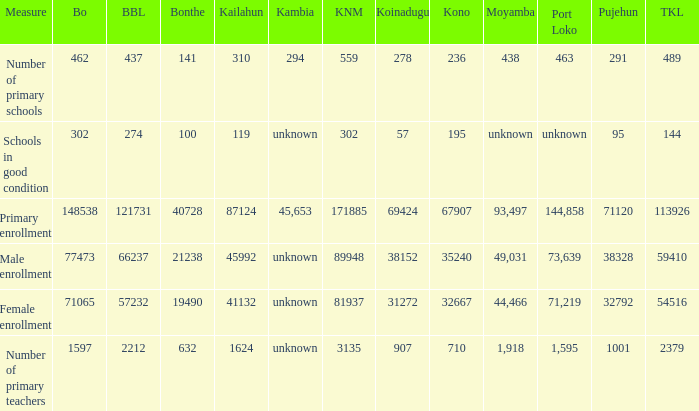Can you give me this table as a dict? {'header': ['Measure', 'Bo', 'BBL', 'Bonthe', 'Kailahun', 'Kambia', 'KNM', 'Koinadugu', 'Kono', 'Moyamba', 'Port Loko', 'Pujehun', 'TKL'], 'rows': [['Number of primary schools', '462', '437', '141', '310', '294', '559', '278', '236', '438', '463', '291', '489'], ['Schools in good condition', '302', '274', '100', '119', 'unknown', '302', '57', '195', 'unknown', 'unknown', '95', '144'], ['Primary enrollment', '148538', '121731', '40728', '87124', '45,653', '171885', '69424', '67907', '93,497', '144,858', '71120', '113926'], ['Male enrollment', '77473', '66237', '21238', '45992', 'unknown', '89948', '38152', '35240', '49,031', '73,639', '38328', '59410'], ['Female enrollment', '71065', '57232', '19490', '41132', 'unknown', '81937', '31272', '32667', '44,466', '71,219', '32792', '54516'], ['Number of primary teachers', '1597', '2212', '632', '1624', 'unknown', '3135', '907', '710', '1,918', '1,595', '1001', '2379']]} What is the lowest number associated with Tonkolili? 144.0. 